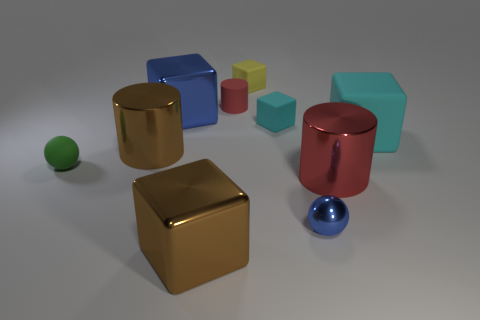Subtract all yellow blocks. How many blocks are left? 4 Subtract 2 cubes. How many cubes are left? 3 Subtract all brown cubes. How many cubes are left? 4 Subtract all brown cubes. Subtract all red cylinders. How many cubes are left? 4 Subtract all balls. How many objects are left? 8 Subtract all green metal cylinders. Subtract all big red things. How many objects are left? 9 Add 1 small green rubber spheres. How many small green rubber spheres are left? 2 Add 2 big yellow shiny cylinders. How many big yellow shiny cylinders exist? 2 Subtract 0 purple cylinders. How many objects are left? 10 